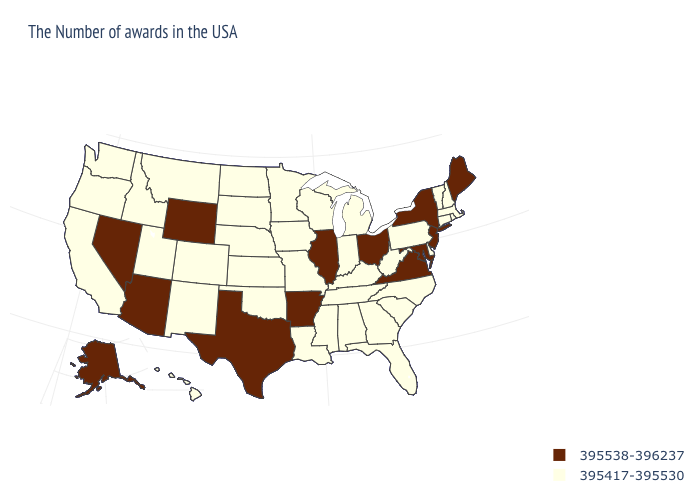Does Wyoming have the highest value in the USA?
Answer briefly. Yes. What is the value of New Mexico?
Be succinct. 395417-395530. What is the value of Kansas?
Keep it brief. 395417-395530. Name the states that have a value in the range 395538-396237?
Be succinct. Maine, New York, New Jersey, Maryland, Virginia, Ohio, Illinois, Arkansas, Texas, Wyoming, Arizona, Nevada, Alaska. What is the value of Tennessee?
Answer briefly. 395417-395530. What is the value of Michigan?
Keep it brief. 395417-395530. Name the states that have a value in the range 395538-396237?
Short answer required. Maine, New York, New Jersey, Maryland, Virginia, Ohio, Illinois, Arkansas, Texas, Wyoming, Arizona, Nevada, Alaska. Does New Mexico have the highest value in the USA?
Quick response, please. No. Which states hav the highest value in the West?
Give a very brief answer. Wyoming, Arizona, Nevada, Alaska. How many symbols are there in the legend?
Short answer required. 2. Name the states that have a value in the range 395538-396237?
Quick response, please. Maine, New York, New Jersey, Maryland, Virginia, Ohio, Illinois, Arkansas, Texas, Wyoming, Arizona, Nevada, Alaska. Among the states that border West Virginia , which have the highest value?
Answer briefly. Maryland, Virginia, Ohio. What is the value of Oregon?
Quick response, please. 395417-395530. Among the states that border Oklahoma , does New Mexico have the highest value?
Short answer required. No. 